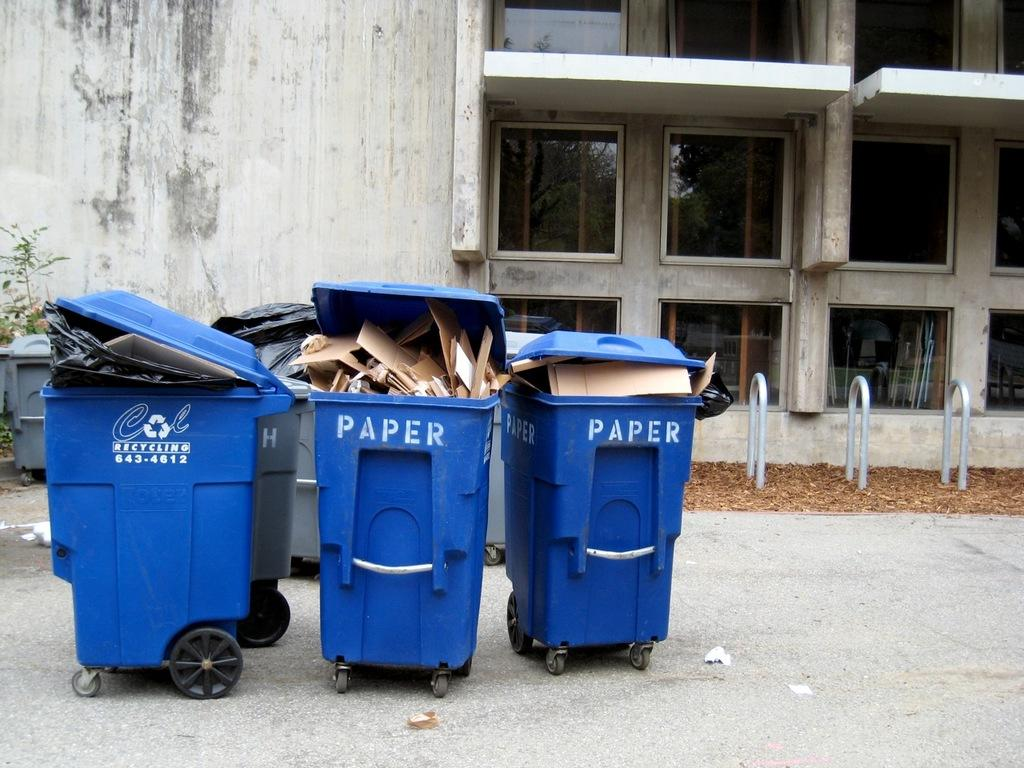<image>
Create a compact narrative representing the image presented. Two trash bins for paper sit next to a bin that says recycling on it. 